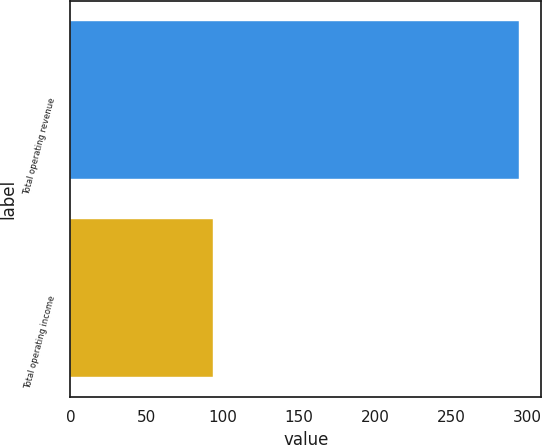<chart> <loc_0><loc_0><loc_500><loc_500><bar_chart><fcel>Total operating revenue<fcel>Total operating income<nl><fcel>294.2<fcel>93.4<nl></chart> 